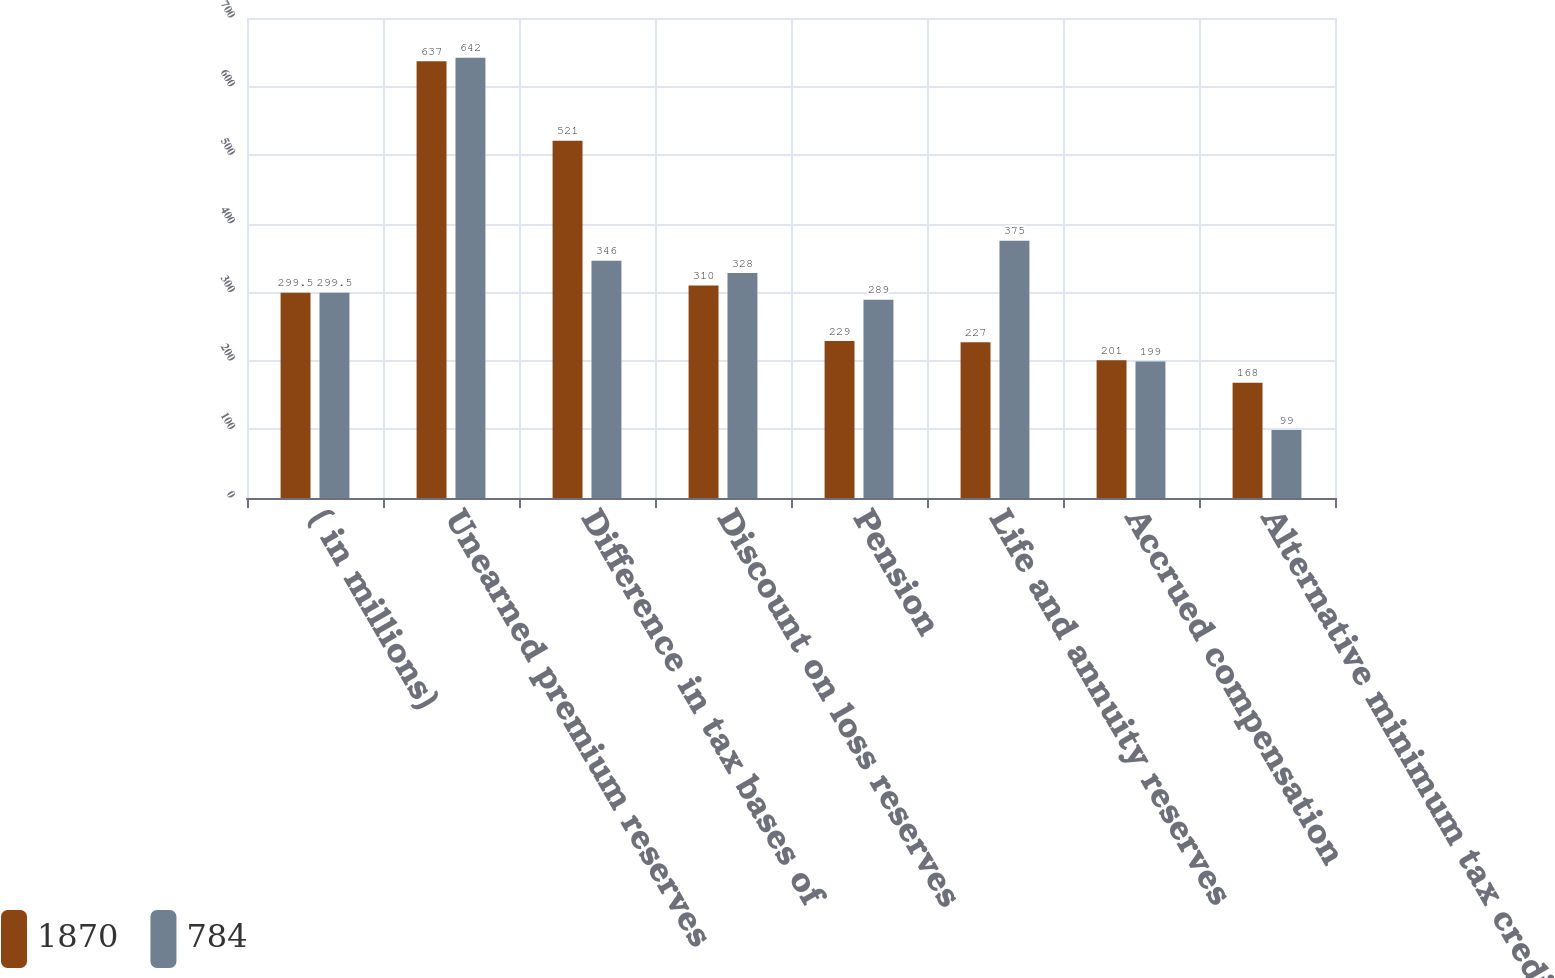Convert chart. <chart><loc_0><loc_0><loc_500><loc_500><stacked_bar_chart><ecel><fcel>( in millions)<fcel>Unearned premium reserves<fcel>Difference in tax bases of<fcel>Discount on loss reserves<fcel>Pension<fcel>Life and annuity reserves<fcel>Accrued compensation<fcel>Alternative minimum tax credit<nl><fcel>1870<fcel>299.5<fcel>637<fcel>521<fcel>310<fcel>229<fcel>227<fcel>201<fcel>168<nl><fcel>784<fcel>299.5<fcel>642<fcel>346<fcel>328<fcel>289<fcel>375<fcel>199<fcel>99<nl></chart> 